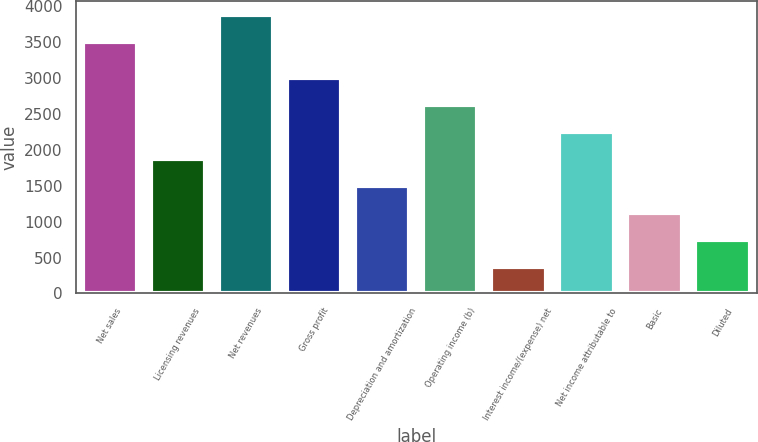<chart> <loc_0><loc_0><loc_500><loc_500><bar_chart><fcel>Net sales<fcel>Licensing revenues<fcel>Net revenues<fcel>Gross profit<fcel>Depreciation and amortization<fcel>Operating income (b)<fcel>Interest income/(expense) net<fcel>Net income attributable to<fcel>Basic<fcel>Diluted<nl><fcel>3501.1<fcel>1873.25<fcel>3875.71<fcel>2997.08<fcel>1498.64<fcel>2622.47<fcel>374.81<fcel>2247.86<fcel>1124.03<fcel>749.42<nl></chart> 